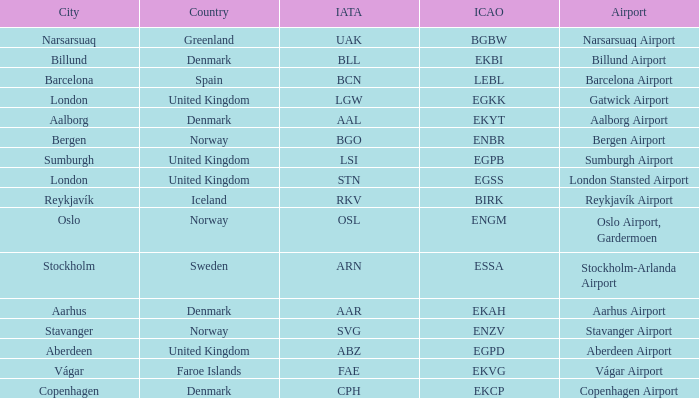What is the ICAO for Denmark, and the IATA is bll? EKBI. 